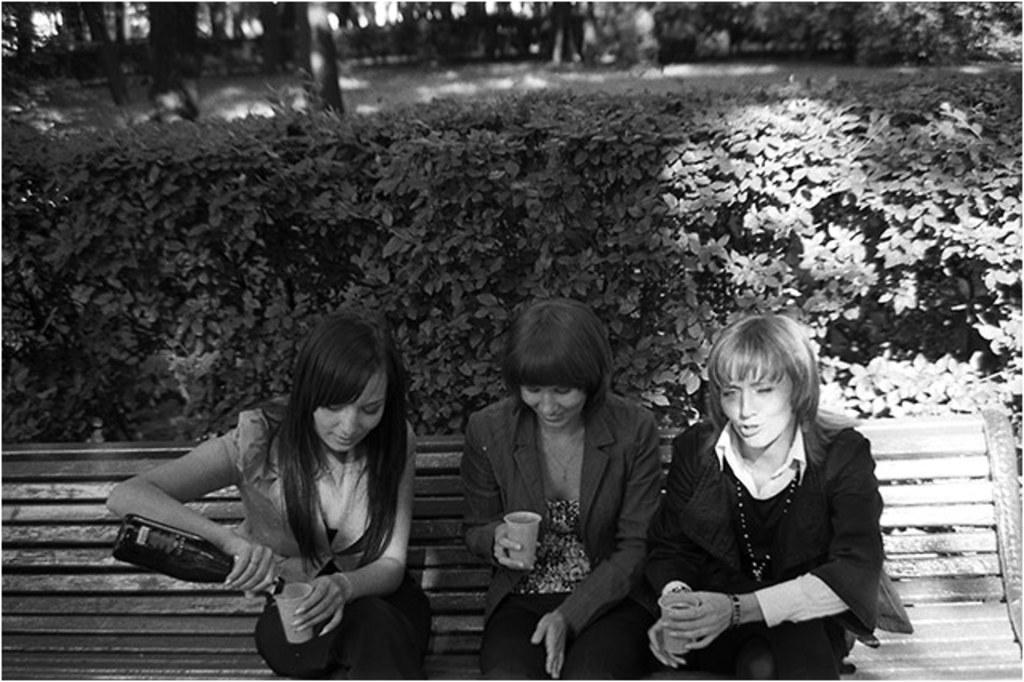How would you summarize this image in a sentence or two? In this picture I can see the bench in front, on which there are 3 women sitting and I see that all of them are holding cups in their hands and the woman on the left is holding a bottle in other hand. In the background I see the plants and the trees and I see that this is a black and white image. 